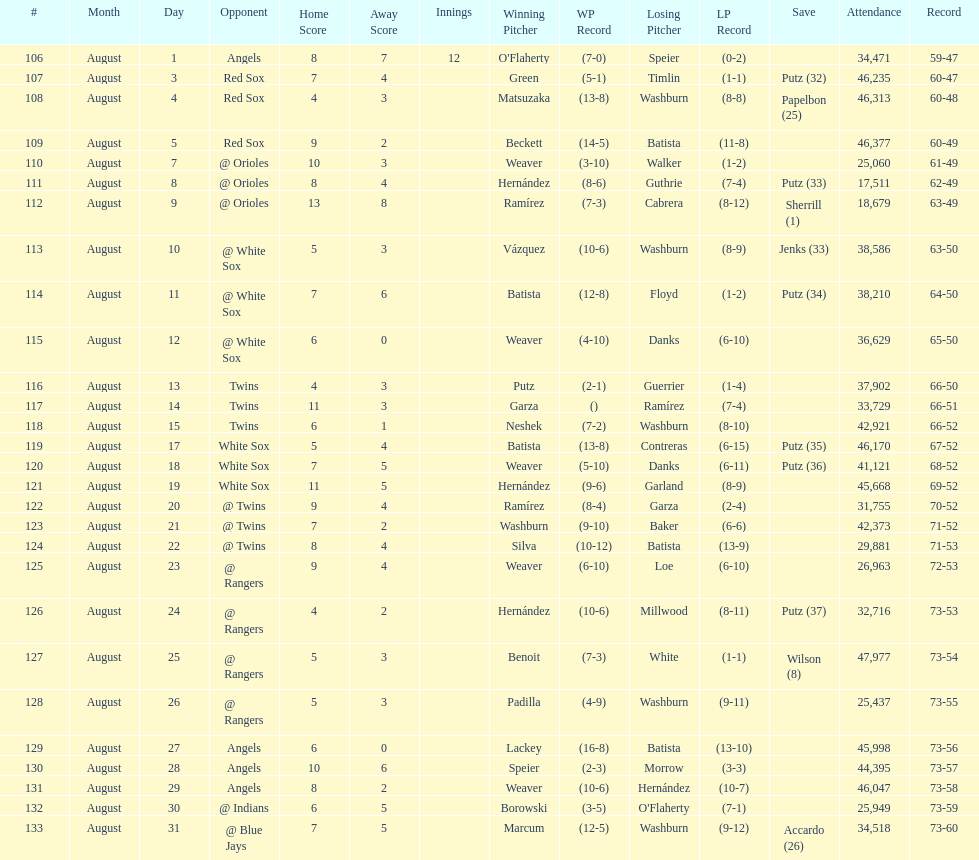How many losses during stretch? 7. 